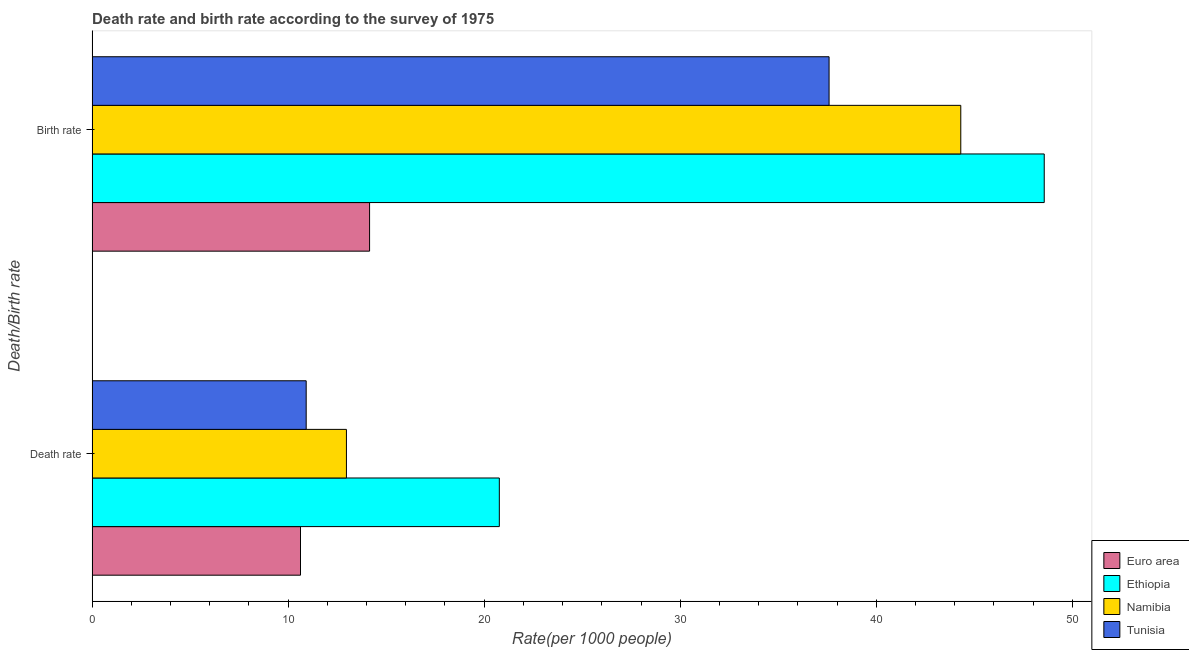How many bars are there on the 2nd tick from the top?
Your answer should be very brief. 4. What is the label of the 2nd group of bars from the top?
Your answer should be compact. Death rate. What is the birth rate in Euro area?
Ensure brevity in your answer.  14.15. Across all countries, what is the maximum death rate?
Give a very brief answer. 20.77. Across all countries, what is the minimum birth rate?
Ensure brevity in your answer.  14.15. In which country was the birth rate maximum?
Provide a short and direct response. Ethiopia. In which country was the birth rate minimum?
Give a very brief answer. Euro area. What is the total death rate in the graph?
Provide a short and direct response. 55.3. What is the difference between the death rate in Tunisia and that in Ethiopia?
Your answer should be compact. -9.85. What is the difference between the birth rate in Euro area and the death rate in Ethiopia?
Your answer should be compact. -6.62. What is the average birth rate per country?
Offer a terse response. 36.16. What is the difference between the death rate and birth rate in Ethiopia?
Offer a very short reply. -27.8. In how many countries, is the birth rate greater than 6 ?
Your response must be concise. 4. What is the ratio of the birth rate in Ethiopia to that in Namibia?
Your answer should be compact. 1.1. Is the birth rate in Euro area less than that in Tunisia?
Offer a terse response. Yes. In how many countries, is the death rate greater than the average death rate taken over all countries?
Provide a succinct answer. 1. What does the 3rd bar from the top in Birth rate represents?
Offer a very short reply. Ethiopia. Are all the bars in the graph horizontal?
Give a very brief answer. Yes. How many countries are there in the graph?
Your answer should be compact. 4. What is the difference between two consecutive major ticks on the X-axis?
Ensure brevity in your answer.  10. Are the values on the major ticks of X-axis written in scientific E-notation?
Give a very brief answer. No. How many legend labels are there?
Keep it short and to the point. 4. What is the title of the graph?
Your answer should be compact. Death rate and birth rate according to the survey of 1975. Does "Croatia" appear as one of the legend labels in the graph?
Offer a very short reply. No. What is the label or title of the X-axis?
Make the answer very short. Rate(per 1000 people). What is the label or title of the Y-axis?
Offer a terse response. Death/Birth rate. What is the Rate(per 1000 people) of Euro area in Death rate?
Offer a terse response. 10.63. What is the Rate(per 1000 people) of Ethiopia in Death rate?
Provide a short and direct response. 20.77. What is the Rate(per 1000 people) in Namibia in Death rate?
Offer a terse response. 12.97. What is the Rate(per 1000 people) in Tunisia in Death rate?
Make the answer very short. 10.92. What is the Rate(per 1000 people) in Euro area in Birth rate?
Make the answer very short. 14.15. What is the Rate(per 1000 people) in Ethiopia in Birth rate?
Your answer should be compact. 48.57. What is the Rate(per 1000 people) in Namibia in Birth rate?
Offer a very short reply. 44.31. What is the Rate(per 1000 people) of Tunisia in Birth rate?
Provide a succinct answer. 37.59. Across all Death/Birth rate, what is the maximum Rate(per 1000 people) of Euro area?
Provide a short and direct response. 14.15. Across all Death/Birth rate, what is the maximum Rate(per 1000 people) in Ethiopia?
Your response must be concise. 48.57. Across all Death/Birth rate, what is the maximum Rate(per 1000 people) in Namibia?
Provide a succinct answer. 44.31. Across all Death/Birth rate, what is the maximum Rate(per 1000 people) of Tunisia?
Offer a very short reply. 37.59. Across all Death/Birth rate, what is the minimum Rate(per 1000 people) in Euro area?
Make the answer very short. 10.63. Across all Death/Birth rate, what is the minimum Rate(per 1000 people) of Ethiopia?
Your answer should be very brief. 20.77. Across all Death/Birth rate, what is the minimum Rate(per 1000 people) in Namibia?
Your answer should be very brief. 12.97. Across all Death/Birth rate, what is the minimum Rate(per 1000 people) in Tunisia?
Offer a terse response. 10.92. What is the total Rate(per 1000 people) in Euro area in the graph?
Make the answer very short. 24.79. What is the total Rate(per 1000 people) of Ethiopia in the graph?
Give a very brief answer. 69.34. What is the total Rate(per 1000 people) of Namibia in the graph?
Give a very brief answer. 57.29. What is the total Rate(per 1000 people) in Tunisia in the graph?
Offer a very short reply. 48.52. What is the difference between the Rate(per 1000 people) in Euro area in Death rate and that in Birth rate?
Provide a short and direct response. -3.52. What is the difference between the Rate(per 1000 people) of Ethiopia in Death rate and that in Birth rate?
Keep it short and to the point. -27.8. What is the difference between the Rate(per 1000 people) of Namibia in Death rate and that in Birth rate?
Your response must be concise. -31.34. What is the difference between the Rate(per 1000 people) in Tunisia in Death rate and that in Birth rate?
Keep it short and to the point. -26.67. What is the difference between the Rate(per 1000 people) in Euro area in Death rate and the Rate(per 1000 people) in Ethiopia in Birth rate?
Offer a terse response. -37.94. What is the difference between the Rate(per 1000 people) of Euro area in Death rate and the Rate(per 1000 people) of Namibia in Birth rate?
Keep it short and to the point. -33.68. What is the difference between the Rate(per 1000 people) of Euro area in Death rate and the Rate(per 1000 people) of Tunisia in Birth rate?
Offer a terse response. -26.96. What is the difference between the Rate(per 1000 people) of Ethiopia in Death rate and the Rate(per 1000 people) of Namibia in Birth rate?
Ensure brevity in your answer.  -23.54. What is the difference between the Rate(per 1000 people) of Ethiopia in Death rate and the Rate(per 1000 people) of Tunisia in Birth rate?
Offer a terse response. -16.82. What is the difference between the Rate(per 1000 people) of Namibia in Death rate and the Rate(per 1000 people) of Tunisia in Birth rate?
Provide a short and direct response. -24.62. What is the average Rate(per 1000 people) in Euro area per Death/Birth rate?
Keep it short and to the point. 12.39. What is the average Rate(per 1000 people) of Ethiopia per Death/Birth rate?
Give a very brief answer. 34.67. What is the average Rate(per 1000 people) of Namibia per Death/Birth rate?
Provide a succinct answer. 28.64. What is the average Rate(per 1000 people) in Tunisia per Death/Birth rate?
Give a very brief answer. 24.26. What is the difference between the Rate(per 1000 people) in Euro area and Rate(per 1000 people) in Ethiopia in Death rate?
Make the answer very short. -10.14. What is the difference between the Rate(per 1000 people) of Euro area and Rate(per 1000 people) of Namibia in Death rate?
Provide a succinct answer. -2.34. What is the difference between the Rate(per 1000 people) of Euro area and Rate(per 1000 people) of Tunisia in Death rate?
Offer a very short reply. -0.29. What is the difference between the Rate(per 1000 people) in Ethiopia and Rate(per 1000 people) in Namibia in Death rate?
Your answer should be very brief. 7.8. What is the difference between the Rate(per 1000 people) of Ethiopia and Rate(per 1000 people) of Tunisia in Death rate?
Offer a terse response. 9.85. What is the difference between the Rate(per 1000 people) in Namibia and Rate(per 1000 people) in Tunisia in Death rate?
Your answer should be compact. 2.05. What is the difference between the Rate(per 1000 people) in Euro area and Rate(per 1000 people) in Ethiopia in Birth rate?
Give a very brief answer. -34.41. What is the difference between the Rate(per 1000 people) in Euro area and Rate(per 1000 people) in Namibia in Birth rate?
Offer a very short reply. -30.16. What is the difference between the Rate(per 1000 people) of Euro area and Rate(per 1000 people) of Tunisia in Birth rate?
Keep it short and to the point. -23.44. What is the difference between the Rate(per 1000 people) in Ethiopia and Rate(per 1000 people) in Namibia in Birth rate?
Provide a short and direct response. 4.26. What is the difference between the Rate(per 1000 people) in Ethiopia and Rate(per 1000 people) in Tunisia in Birth rate?
Provide a succinct answer. 10.97. What is the difference between the Rate(per 1000 people) of Namibia and Rate(per 1000 people) of Tunisia in Birth rate?
Ensure brevity in your answer.  6.72. What is the ratio of the Rate(per 1000 people) in Euro area in Death rate to that in Birth rate?
Make the answer very short. 0.75. What is the ratio of the Rate(per 1000 people) in Ethiopia in Death rate to that in Birth rate?
Your answer should be very brief. 0.43. What is the ratio of the Rate(per 1000 people) in Namibia in Death rate to that in Birth rate?
Offer a terse response. 0.29. What is the ratio of the Rate(per 1000 people) in Tunisia in Death rate to that in Birth rate?
Give a very brief answer. 0.29. What is the difference between the highest and the second highest Rate(per 1000 people) of Euro area?
Keep it short and to the point. 3.52. What is the difference between the highest and the second highest Rate(per 1000 people) in Ethiopia?
Give a very brief answer. 27.8. What is the difference between the highest and the second highest Rate(per 1000 people) in Namibia?
Provide a succinct answer. 31.34. What is the difference between the highest and the second highest Rate(per 1000 people) in Tunisia?
Ensure brevity in your answer.  26.67. What is the difference between the highest and the lowest Rate(per 1000 people) in Euro area?
Offer a very short reply. 3.52. What is the difference between the highest and the lowest Rate(per 1000 people) in Ethiopia?
Provide a short and direct response. 27.8. What is the difference between the highest and the lowest Rate(per 1000 people) in Namibia?
Provide a short and direct response. 31.34. What is the difference between the highest and the lowest Rate(per 1000 people) in Tunisia?
Your answer should be compact. 26.67. 